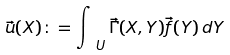Convert formula to latex. <formula><loc_0><loc_0><loc_500><loc_500>\vec { u } ( X ) \colon = \int _ { \ U } \vec { \Gamma } ( X , Y ) \vec { f } ( Y ) \, d Y</formula> 